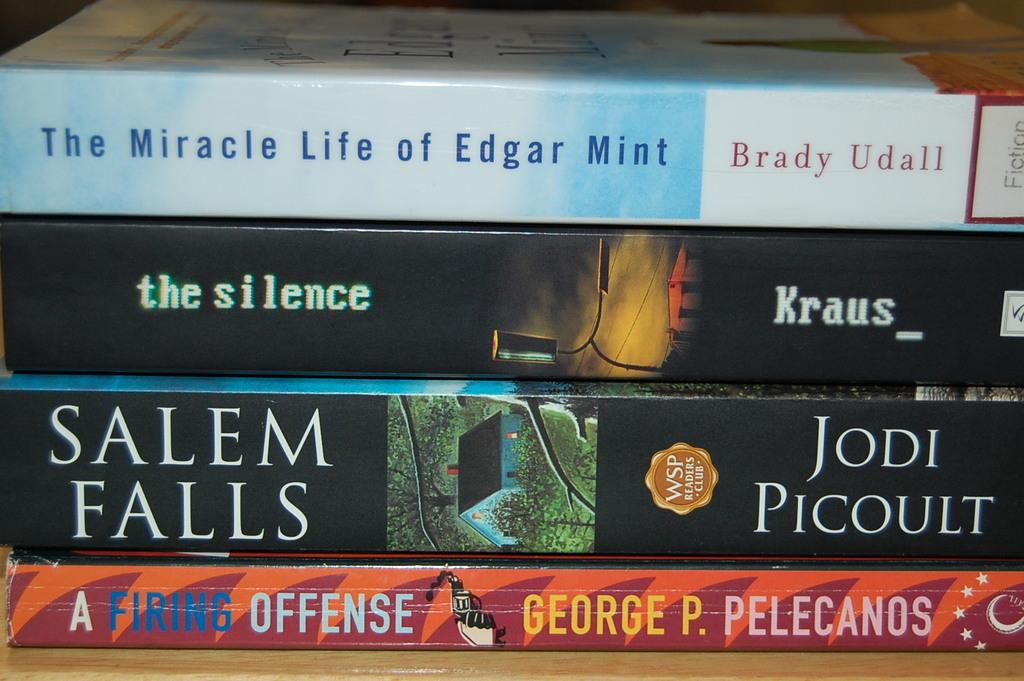<image>
Create a compact narrative representing the image presented. A book called Salem Falls sits in the middle of a stack of books 